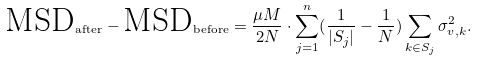Convert formula to latex. <formula><loc_0><loc_0><loc_500><loc_500>\text {MSD} _ { \text {after} } - \text {MSD} _ { \text {before} } = \frac { \mu M } { 2 N } \cdot \sum _ { j = 1 } ^ { n } ( \frac { 1 } { | S _ { j } | } - \frac { 1 } { N } ) \sum _ { k \in S _ { j } } \sigma _ { v , k } ^ { 2 } .</formula> 